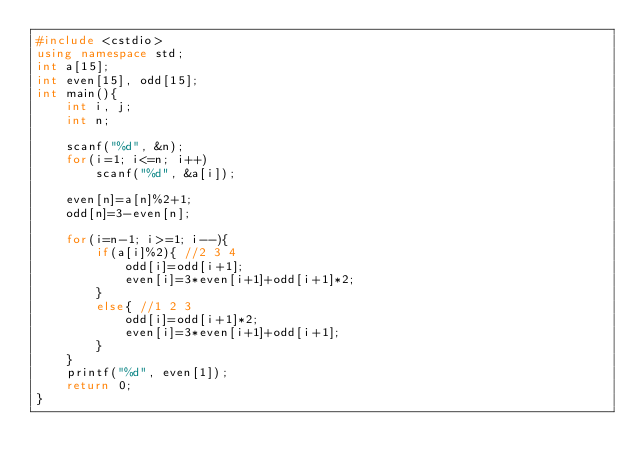<code> <loc_0><loc_0><loc_500><loc_500><_C++_>#include <cstdio>
using namespace std;
int a[15];
int even[15], odd[15];
int main(){
	int i, j;
	int n;
	
	scanf("%d", &n);
	for(i=1; i<=n; i++)
		scanf("%d", &a[i]);
		
	even[n]=a[n]%2+1;
	odd[n]=3-even[n];

	for(i=n-1; i>=1; i--){
		if(a[i]%2){ //2 3 4
			odd[i]=odd[i+1];
			even[i]=3*even[i+1]+odd[i+1]*2;
		}
		else{ //1 2 3
			odd[i]=odd[i+1]*2;
			even[i]=3*even[i+1]+odd[i+1];
		}
	}
	printf("%d", even[1]);
	return 0;
}</code> 